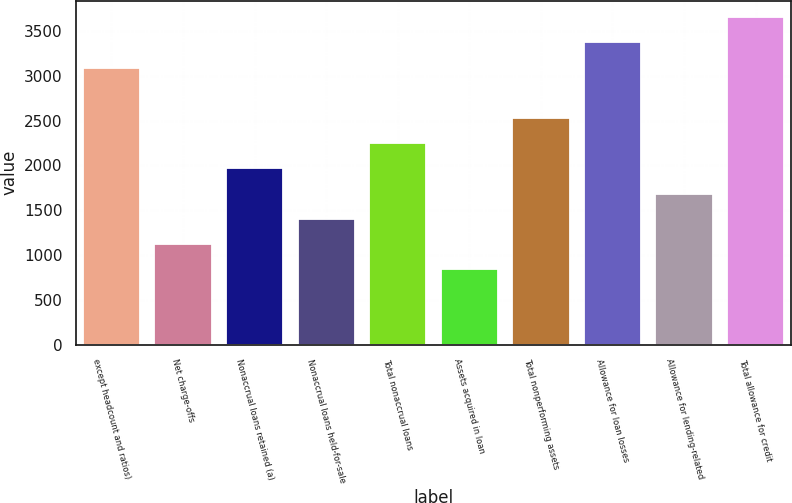Convert chart. <chart><loc_0><loc_0><loc_500><loc_500><bar_chart><fcel>except headcount and ratios)<fcel>Net charge-offs<fcel>Nonaccrual loans retained (a)<fcel>Nonaccrual loans held-for-sale<fcel>Total nonaccrual loans<fcel>Assets acquired in loan<fcel>Total nonperforming assets<fcel>Allowance for loan losses<fcel>Allowance for lending-related<fcel>Total allowance for credit<nl><fcel>3092.13<fcel>1124.43<fcel>1967.73<fcel>1405.53<fcel>2248.83<fcel>843.33<fcel>2529.93<fcel>3373.23<fcel>1686.63<fcel>3654.33<nl></chart> 